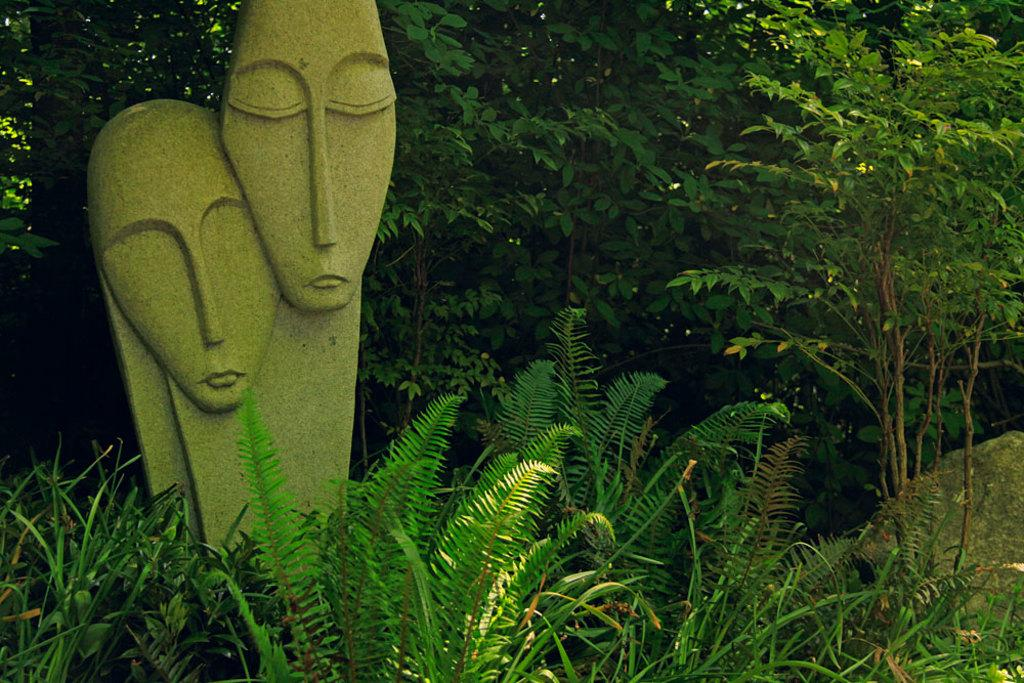How many statues are in the image? There are two statues in the image. What color are the statues? The statues are green in color. What can be seen in the background of the image? There are plants and trees in the background of the image. What color are the plants and trees? The plants and trees are green in color. What is the purpose of the statues' voices in the image? There are no voices present in the image, as statues are inanimate objects and cannot speak or have a purpose. 